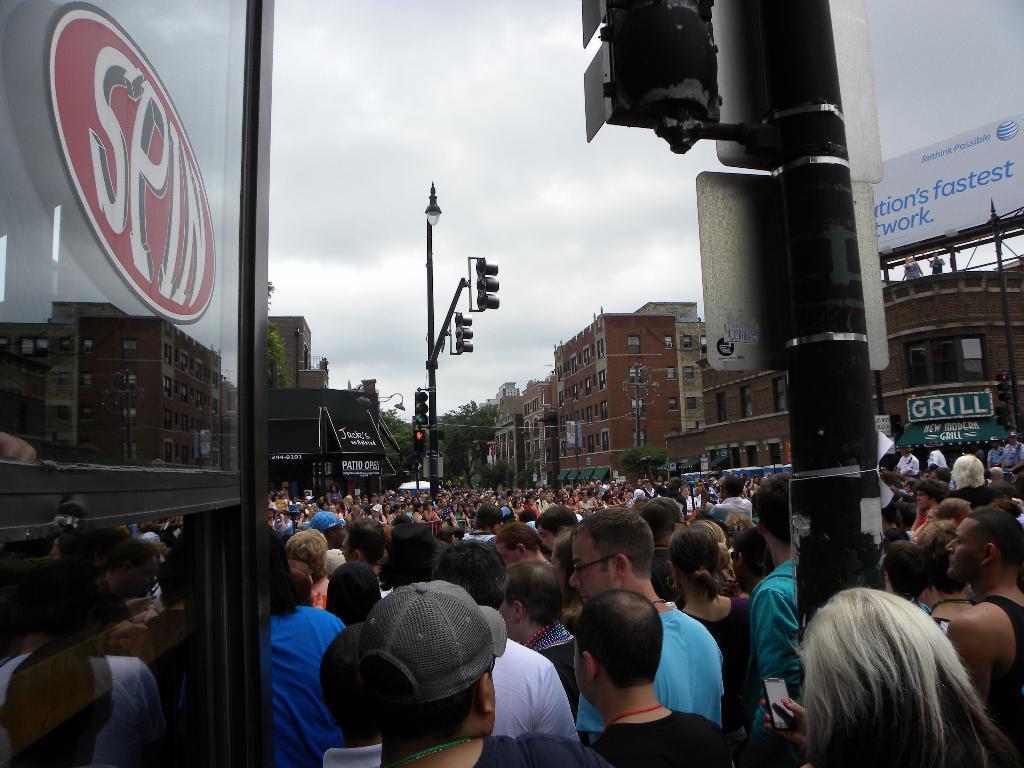Please provide a concise description of this image. In this picture there are many people standing on the road. In the front there is a glass door and street pole. Behind there is a brown color buildings and street pole. 